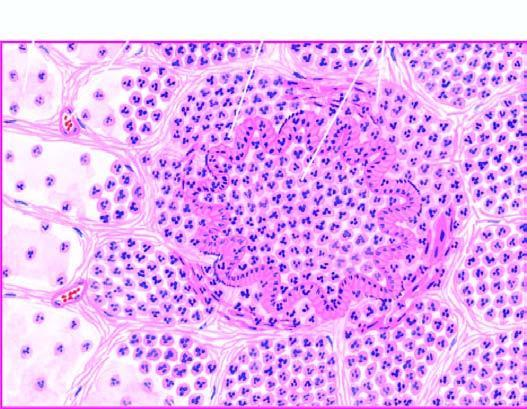what are thickened due to congested capillaries and neutrophilic infiltrate?
Answer the question using a single word or phrase. The alveolar septa infiltrate 